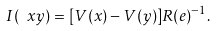Convert formula to latex. <formula><loc_0><loc_0><loc_500><loc_500>I ( \ x y ) = [ V ( x ) - V ( y ) ] R ( e ) ^ { - 1 } .</formula> 